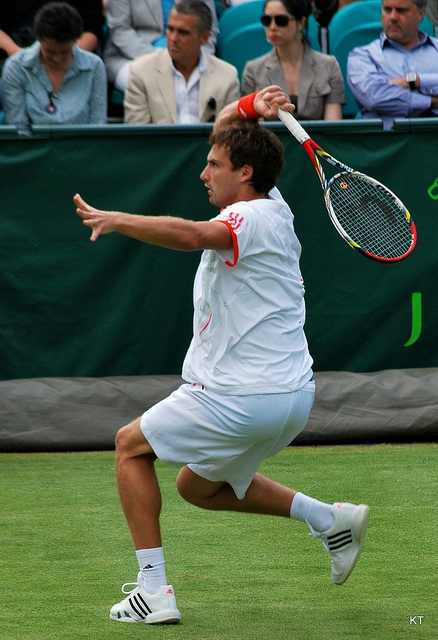Describe the objects in this image and their specific colors. I can see people in black, lavender, and darkgray tones, people in black, teal, blue, and gray tones, people in black, darkgray, maroon, and gray tones, people in black, darkgray, gray, and maroon tones, and tennis racket in black, teal, and lightgray tones in this image. 